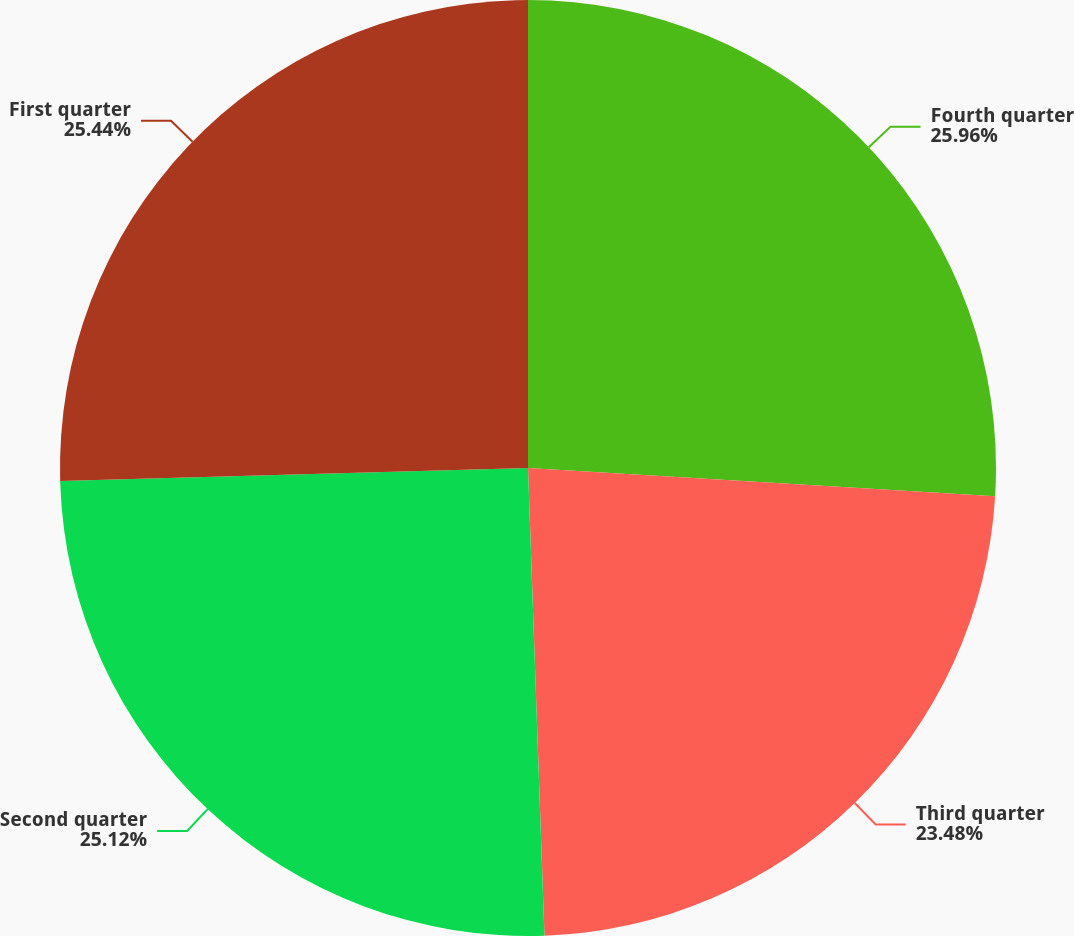<chart> <loc_0><loc_0><loc_500><loc_500><pie_chart><fcel>Fourth quarter<fcel>Third quarter<fcel>Second quarter<fcel>First quarter<nl><fcel>25.96%<fcel>23.48%<fcel>25.12%<fcel>25.44%<nl></chart> 